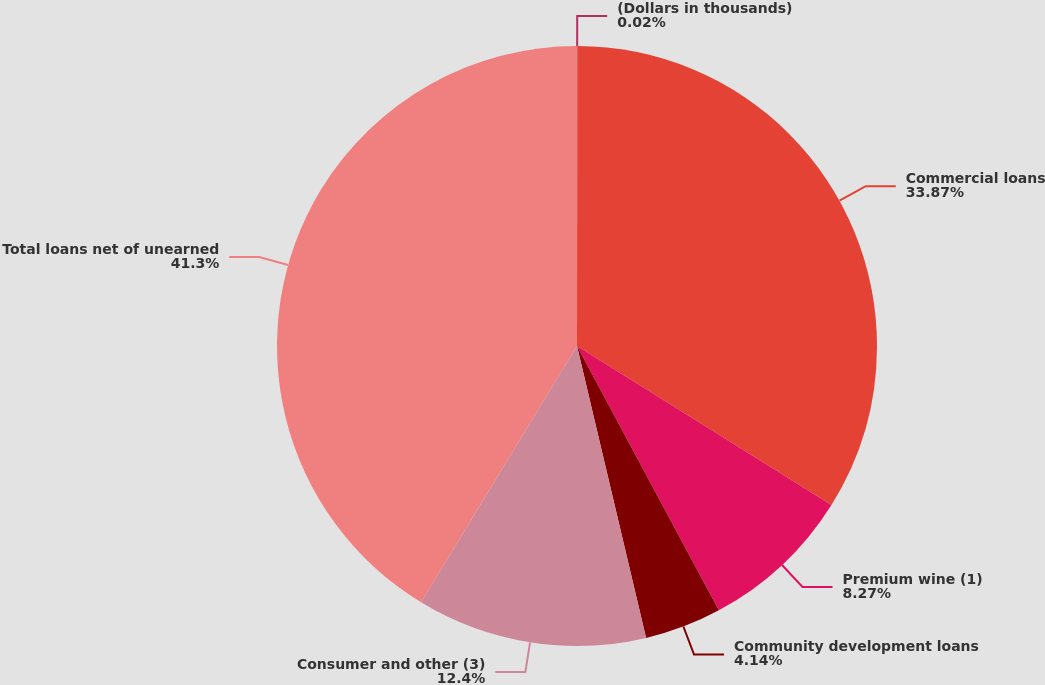Convert chart. <chart><loc_0><loc_0><loc_500><loc_500><pie_chart><fcel>(Dollars in thousands)<fcel>Commercial loans<fcel>Premium wine (1)<fcel>Community development loans<fcel>Consumer and other (3)<fcel>Total loans net of unearned<nl><fcel>0.02%<fcel>33.87%<fcel>8.27%<fcel>4.14%<fcel>12.4%<fcel>41.3%<nl></chart> 